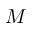Convert formula to latex. <formula><loc_0><loc_0><loc_500><loc_500>M</formula> 